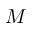Convert formula to latex. <formula><loc_0><loc_0><loc_500><loc_500>M</formula> 